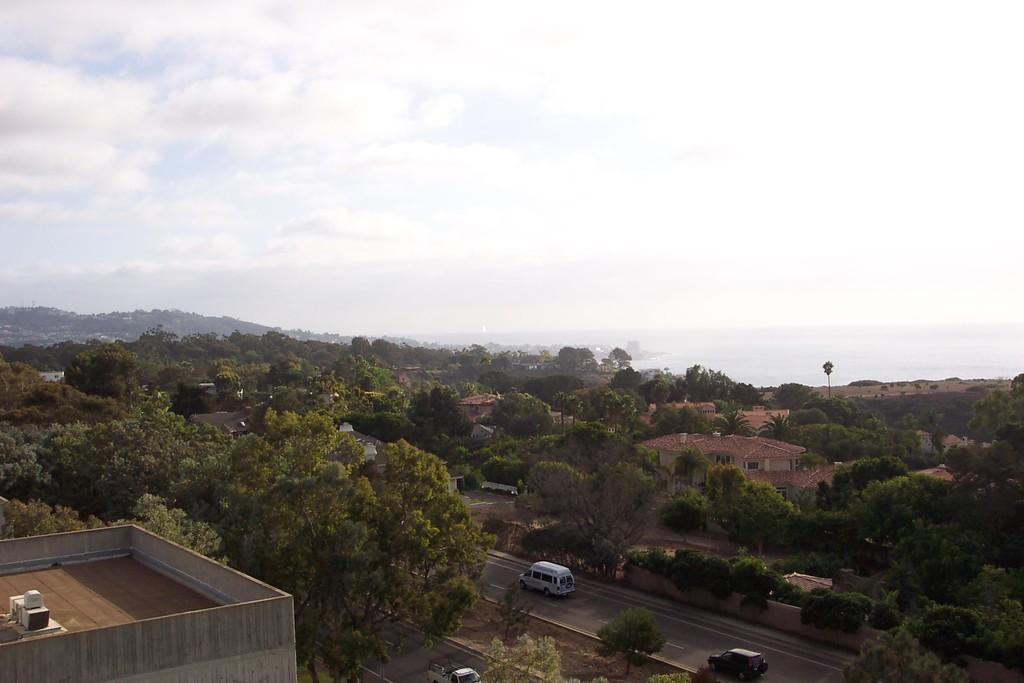What structure is located in the left corner of the image? There is a building in the left corner of the image. What can be seen in the middle of the image? There is a road in the image. What is moving along the road in the image? There are vehicles on the road. What can be seen in the background of the image? There are buildings and trees in the background of the image. Can you describe the maid's attire in the image? There is no maid present in the image. How many legs does the building in the left corner have? Buildings do not have legs; they are stationary structures. 